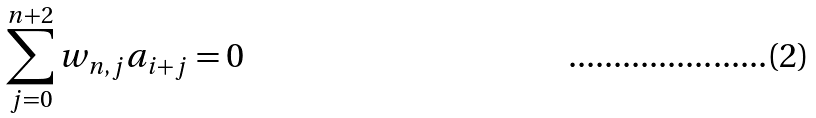<formula> <loc_0><loc_0><loc_500><loc_500>\sum _ { j = 0 } ^ { n + 2 } w _ { n , j } a _ { i + j } = 0</formula> 